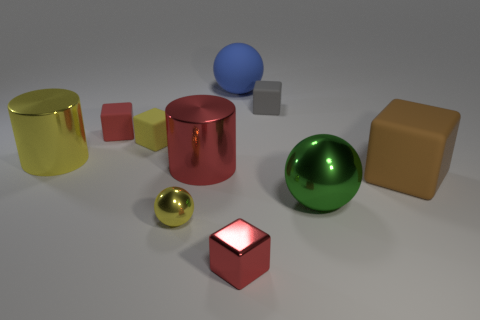How many things are purple rubber blocks or metal cylinders?
Make the answer very short. 2. Is the size of the brown matte block on the right side of the large yellow object the same as the cylinder that is left of the large red metal cylinder?
Ensure brevity in your answer.  Yes. How many other objects are the same size as the green thing?
Provide a succinct answer. 4. How many things are either objects that are on the right side of the small gray matte block or small blocks left of the tiny gray matte block?
Your answer should be very brief. 5. Is the material of the gray object the same as the sphere that is behind the big brown cube?
Give a very brief answer. Yes. How many other things are there of the same shape as the big yellow object?
Make the answer very short. 1. There is a big cylinder that is on the left side of the shiny ball that is in front of the shiny ball that is on the right side of the big blue ball; what is it made of?
Your response must be concise. Metal. Are there an equal number of large brown cubes that are in front of the green metallic ball and small red rubber cubes?
Your answer should be compact. No. Does the red block behind the large brown block have the same material as the tiny block that is in front of the yellow cylinder?
Your response must be concise. No. Are there any other things that have the same material as the big red cylinder?
Keep it short and to the point. Yes. 